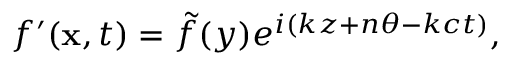<formula> <loc_0><loc_0><loc_500><loc_500>\begin{array} { r } { f ^ { \prime } ( x , t ) = \tilde { f } ( y ) e ^ { i ( k z + n \theta - k c t ) } , } \end{array}</formula> 